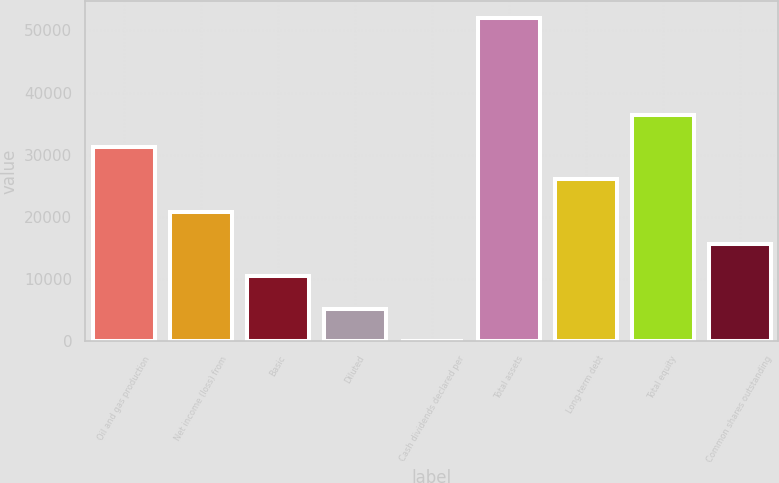Convert chart to OTSL. <chart><loc_0><loc_0><loc_500><loc_500><bar_chart><fcel>Oil and gas production<fcel>Net income (loss) from<fcel>Basic<fcel>Diluted<fcel>Cash dividends declared per<fcel>Total assets<fcel>Long-term debt<fcel>Total equity<fcel>Common shares outstanding<nl><fcel>31230.8<fcel>20820.8<fcel>10410.7<fcel>5205.64<fcel>0.6<fcel>52051<fcel>26025.8<fcel>36435.9<fcel>15615.7<nl></chart> 